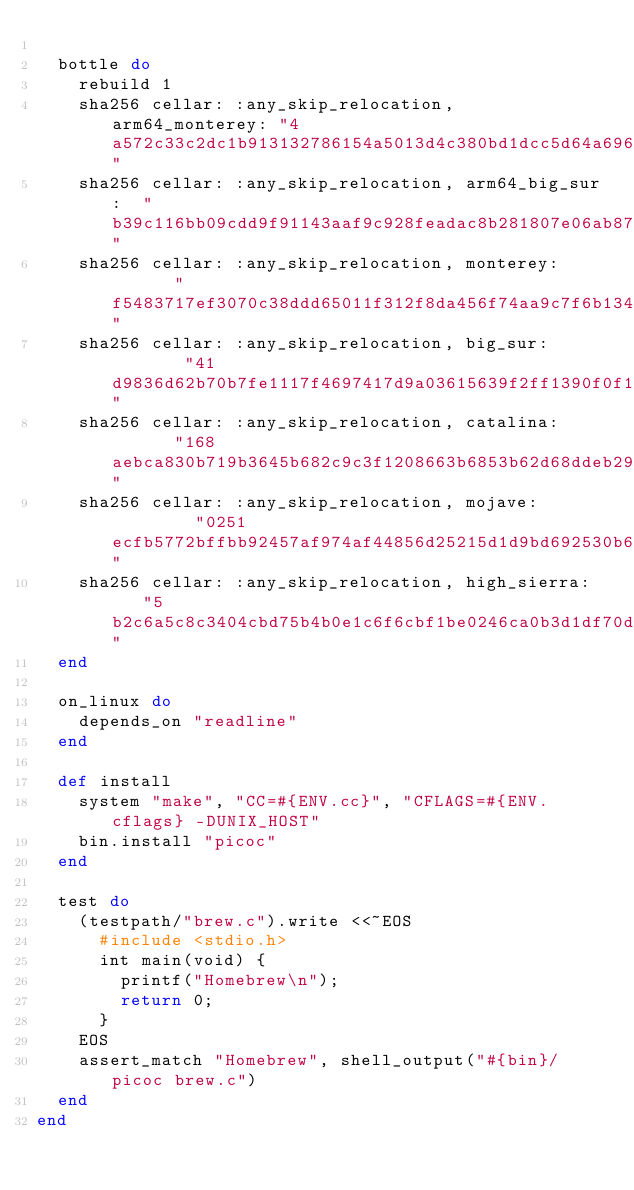Convert code to text. <code><loc_0><loc_0><loc_500><loc_500><_Ruby_>
  bottle do
    rebuild 1
    sha256 cellar: :any_skip_relocation, arm64_monterey: "4a572c33c2dc1b913132786154a5013d4c380bd1dcc5d64a696071ccb15b2589"
    sha256 cellar: :any_skip_relocation, arm64_big_sur:  "b39c116bb09cdd9f91143aaf9c928feadac8b281807e06ab87c4ca2992c13ec4"
    sha256 cellar: :any_skip_relocation, monterey:       "f5483717ef3070c38ddd65011f312f8da456f74aa9c7f6b13480d4e40aa52782"
    sha256 cellar: :any_skip_relocation, big_sur:        "41d9836d62b70b7fe1117f4697417d9a03615639f2ff1390f0f1d21003426bb1"
    sha256 cellar: :any_skip_relocation, catalina:       "168aebca830b719b3645b682c9c3f1208663b6853b62d68ddeb2957ee6c8bc07"
    sha256 cellar: :any_skip_relocation, mojave:         "0251ecfb5772bffbb92457af974af44856d25215d1d9bd692530b6b53517f71a"
    sha256 cellar: :any_skip_relocation, high_sierra:    "5b2c6a5c8c3404cbd75b4b0e1c6f6cbf1be0246ca0b3d1df70d78a6785e51711"
  end

  on_linux do
    depends_on "readline"
  end

  def install
    system "make", "CC=#{ENV.cc}", "CFLAGS=#{ENV.cflags} -DUNIX_HOST"
    bin.install "picoc"
  end

  test do
    (testpath/"brew.c").write <<~EOS
      #include <stdio.h>
      int main(void) {
        printf("Homebrew\n");
        return 0;
      }
    EOS
    assert_match "Homebrew", shell_output("#{bin}/picoc brew.c")
  end
end
</code> 